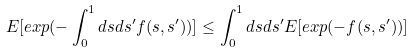<formula> <loc_0><loc_0><loc_500><loc_500>E [ e x p ( - \int _ { 0 } ^ { 1 } d s d s ^ { \prime } f ( s , s ^ { \prime } ) ) ] \leq \int _ { 0 } ^ { 1 } d s d s ^ { \prime } E [ e x p ( - f ( s , s ^ { \prime } ) ) ]</formula> 